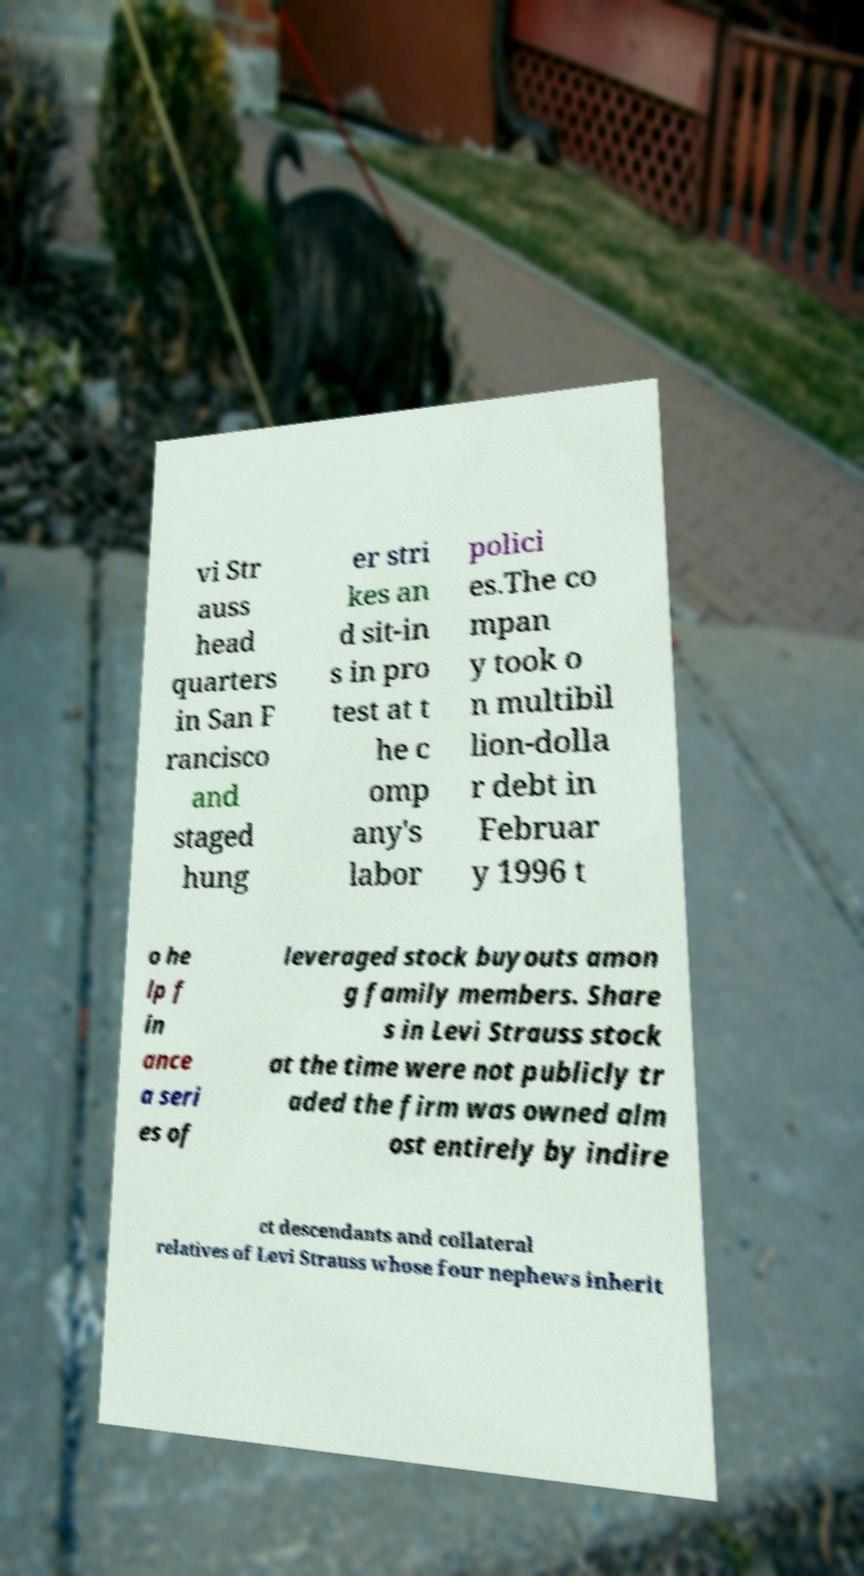Please identify and transcribe the text found in this image. vi Str auss head quarters in San F rancisco and staged hung er stri kes an d sit-in s in pro test at t he c omp any's labor polici es.The co mpan y took o n multibil lion-dolla r debt in Februar y 1996 t o he lp f in ance a seri es of leveraged stock buyouts amon g family members. Share s in Levi Strauss stock at the time were not publicly tr aded the firm was owned alm ost entirely by indire ct descendants and collateral relatives of Levi Strauss whose four nephews inherit 